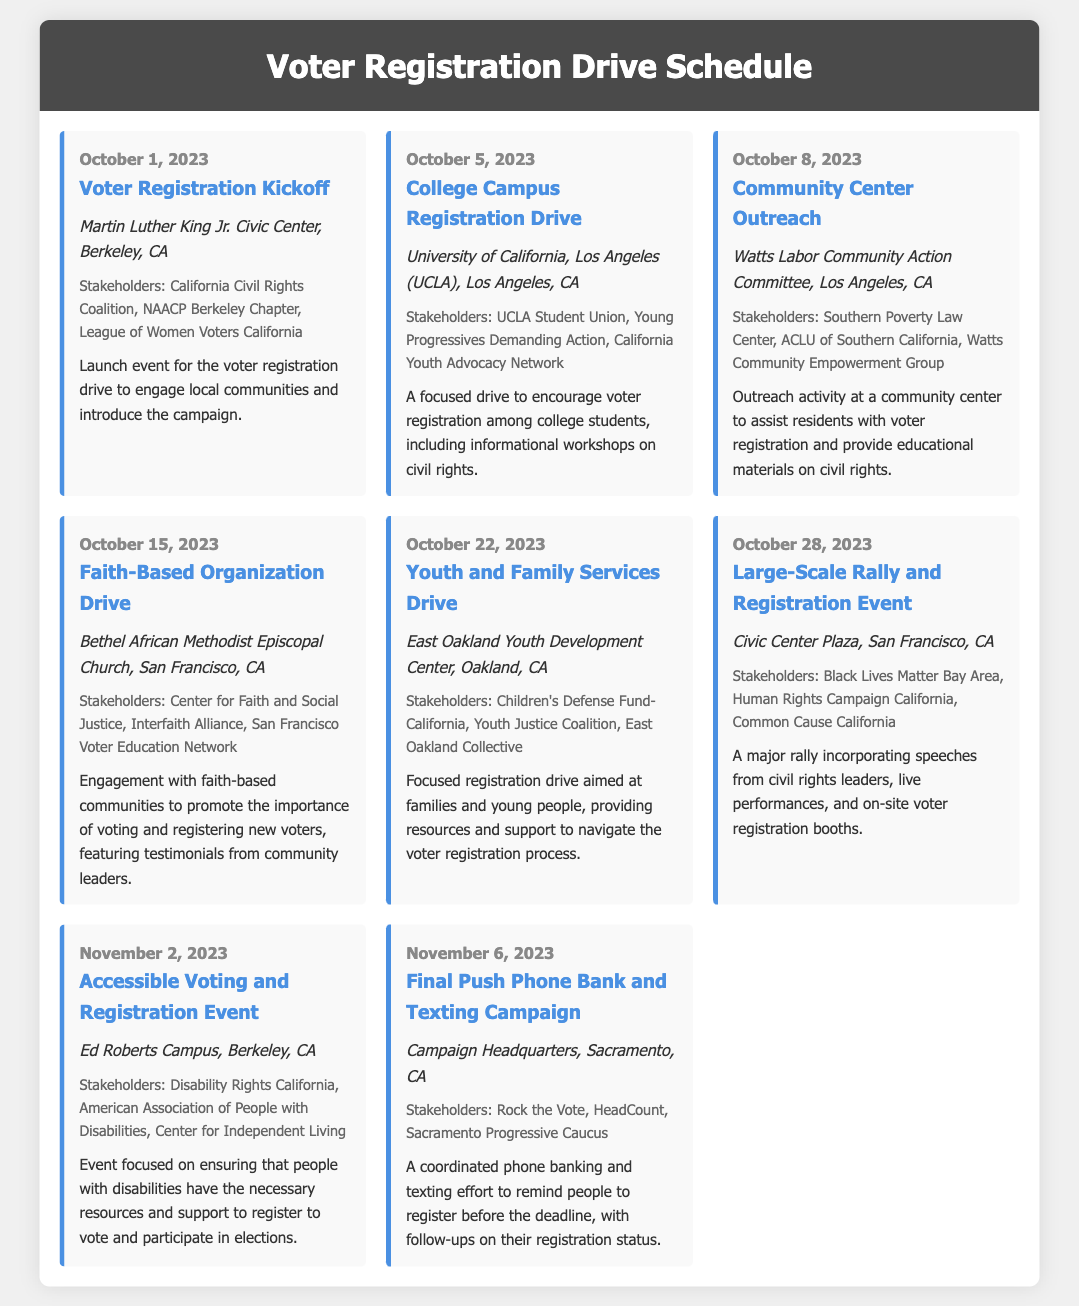What is the date of the Voter Registration Kickoff? The date is clearly stated in the event section for the Voter Registration Kickoff.
Answer: October 1, 2023 Who are the stakeholders for the Large-Scale Rally and Registration Event? The stakeholders are listed in the event description for the Large-Scale Rally.
Answer: Black Lives Matter Bay Area, Human Rights Campaign California, Common Cause California What is the location of the Community Center Outreach? The location for the Community Center Outreach is specified in the event details.
Answer: Watts Labor Community Action Committee, Los Angeles, CA How many days are there between the College Campus Registration Drive and the Faith-Based Organization Drive? The dates of the events allow us to count the days between them: October 5 to October 15 is 10 days.
Answer: 10 days Which event is focused on accessible voting for people with disabilities? The event title indicates this focus on accessibility for people with disabilities.
Answer: Accessible Voting and Registration Event What is the main purpose of the Youth and Family Services Drive? The event description outlines the main focus of this drive for families and young people.
Answer: Providing resources and support to navigate the voter registration process Where does the Final Push Phone Bank and Texting Campaign take place? The location of the Final Push Phone Bank and Texting Campaign is detailed in the event.
Answer: Campaign Headquarters, Sacramento, CA What type of event is scheduled for October 28, 2023? The title and event details indicate the nature of the event happening on that date.
Answer: Rally and Registration Event 